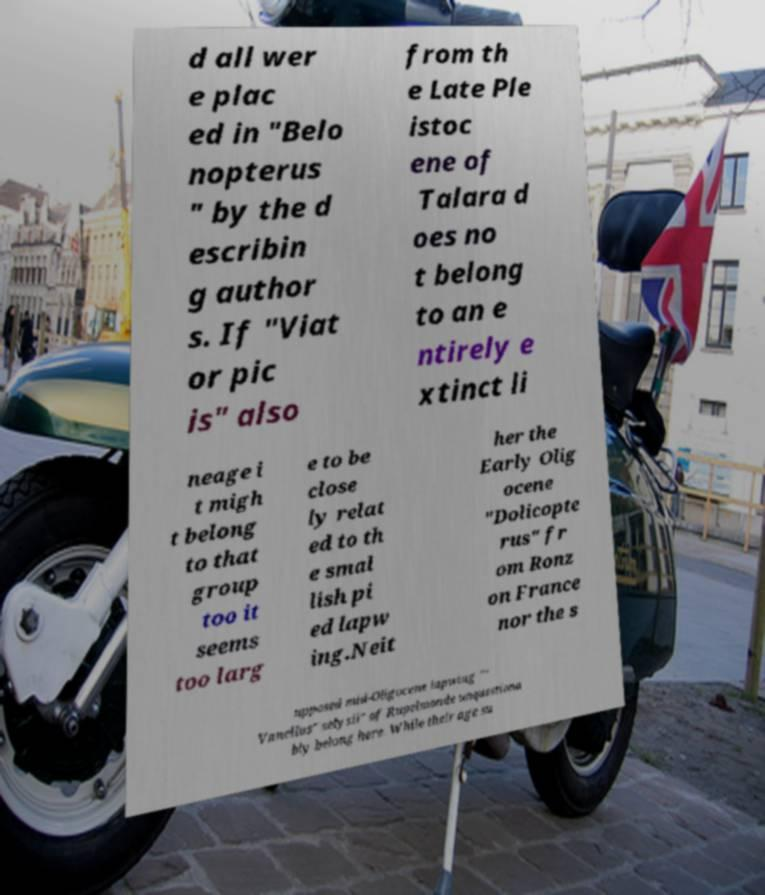Please read and relay the text visible in this image. What does it say? d all wer e plac ed in "Belo nopterus " by the d escribin g author s. If "Viat or pic is" also from th e Late Ple istoc ene of Talara d oes no t belong to an e ntirely e xtinct li neage i t migh t belong to that group too it seems too larg e to be close ly relat ed to th e smal lish pi ed lapw ing.Neit her the Early Olig ocene "Dolicopte rus" fr om Ronz on France nor the s upposed mid-Oligocene lapwing "" Vanellus" selysii" of Rupelmonde unquestiona bly belong here. While their age su 